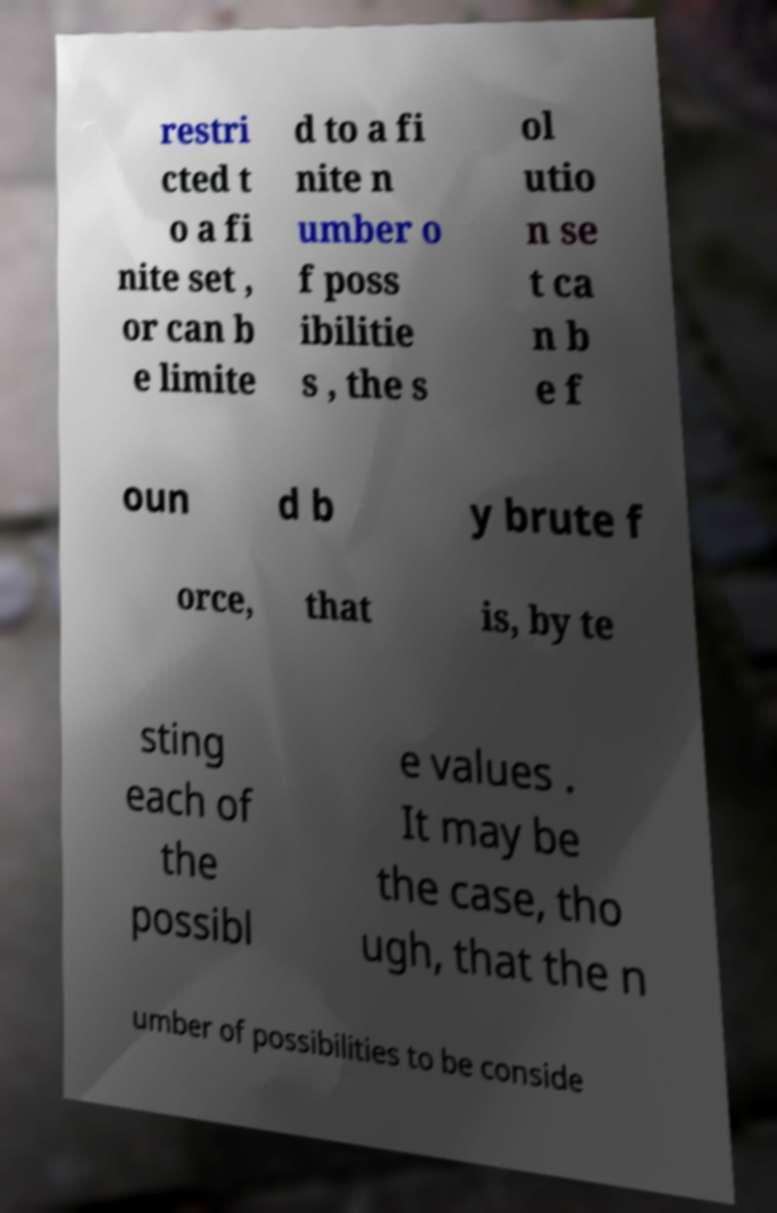Please identify and transcribe the text found in this image. restri cted t o a fi nite set , or can b e limite d to a fi nite n umber o f poss ibilitie s , the s ol utio n se t ca n b e f oun d b y brute f orce, that is, by te sting each of the possibl e values . It may be the case, tho ugh, that the n umber of possibilities to be conside 